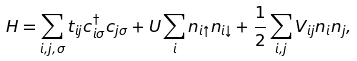Convert formula to latex. <formula><loc_0><loc_0><loc_500><loc_500>H = \sum _ { i , j , \sigma } t _ { i j } c _ { i \sigma } ^ { \dagger } c _ { j \sigma } + U \sum _ { i } n _ { i \uparrow } n _ { i \downarrow } + \frac { 1 } { 2 } \sum _ { i , j } V _ { i j } n _ { i } n _ { j } ,</formula> 